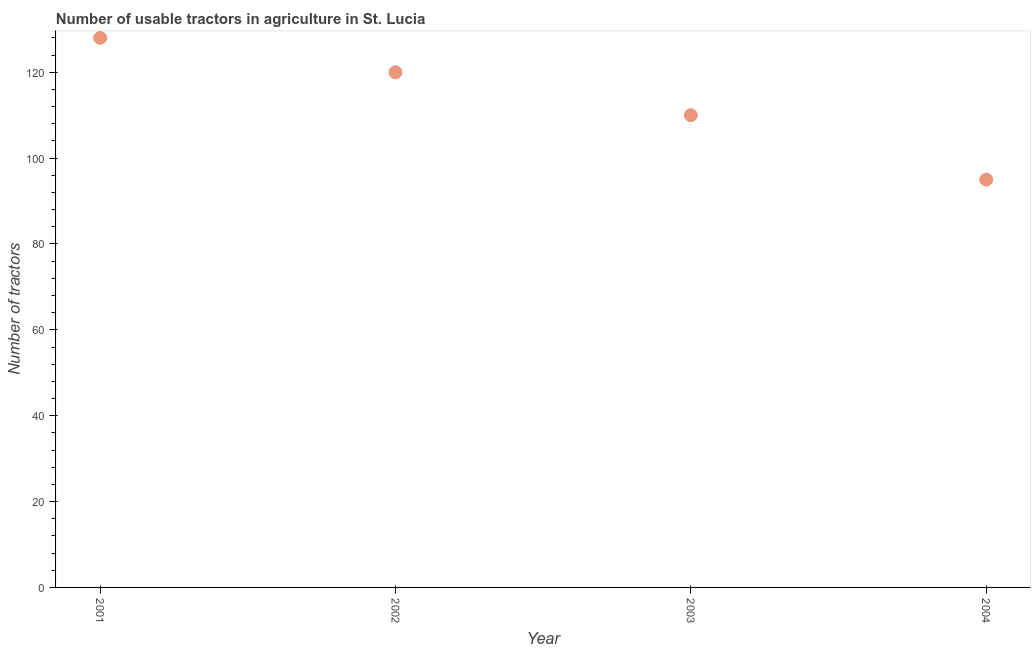What is the number of tractors in 2002?
Offer a very short reply. 120. Across all years, what is the maximum number of tractors?
Your response must be concise. 128. Across all years, what is the minimum number of tractors?
Keep it short and to the point. 95. What is the sum of the number of tractors?
Provide a short and direct response. 453. What is the difference between the number of tractors in 2001 and 2004?
Provide a short and direct response. 33. What is the average number of tractors per year?
Provide a short and direct response. 113.25. What is the median number of tractors?
Your answer should be very brief. 115. In how many years, is the number of tractors greater than 92 ?
Give a very brief answer. 4. Do a majority of the years between 2004 and 2003 (inclusive) have number of tractors greater than 4 ?
Ensure brevity in your answer.  No. What is the ratio of the number of tractors in 2001 to that in 2003?
Your answer should be very brief. 1.16. Is the number of tractors in 2001 less than that in 2004?
Provide a succinct answer. No. Is the difference between the number of tractors in 2001 and 2003 greater than the difference between any two years?
Give a very brief answer. No. Is the sum of the number of tractors in 2003 and 2004 greater than the maximum number of tractors across all years?
Provide a succinct answer. Yes. What is the difference between the highest and the lowest number of tractors?
Give a very brief answer. 33. Does the graph contain any zero values?
Your answer should be compact. No. Does the graph contain grids?
Give a very brief answer. No. What is the title of the graph?
Give a very brief answer. Number of usable tractors in agriculture in St. Lucia. What is the label or title of the X-axis?
Make the answer very short. Year. What is the label or title of the Y-axis?
Give a very brief answer. Number of tractors. What is the Number of tractors in 2001?
Make the answer very short. 128. What is the Number of tractors in 2002?
Your response must be concise. 120. What is the Number of tractors in 2003?
Ensure brevity in your answer.  110. What is the Number of tractors in 2004?
Your response must be concise. 95. What is the difference between the Number of tractors in 2001 and 2002?
Give a very brief answer. 8. What is the difference between the Number of tractors in 2001 and 2003?
Offer a very short reply. 18. What is the difference between the Number of tractors in 2002 and 2003?
Keep it short and to the point. 10. What is the difference between the Number of tractors in 2002 and 2004?
Your response must be concise. 25. What is the difference between the Number of tractors in 2003 and 2004?
Your response must be concise. 15. What is the ratio of the Number of tractors in 2001 to that in 2002?
Provide a short and direct response. 1.07. What is the ratio of the Number of tractors in 2001 to that in 2003?
Make the answer very short. 1.16. What is the ratio of the Number of tractors in 2001 to that in 2004?
Ensure brevity in your answer.  1.35. What is the ratio of the Number of tractors in 2002 to that in 2003?
Offer a very short reply. 1.09. What is the ratio of the Number of tractors in 2002 to that in 2004?
Your answer should be very brief. 1.26. What is the ratio of the Number of tractors in 2003 to that in 2004?
Provide a succinct answer. 1.16. 